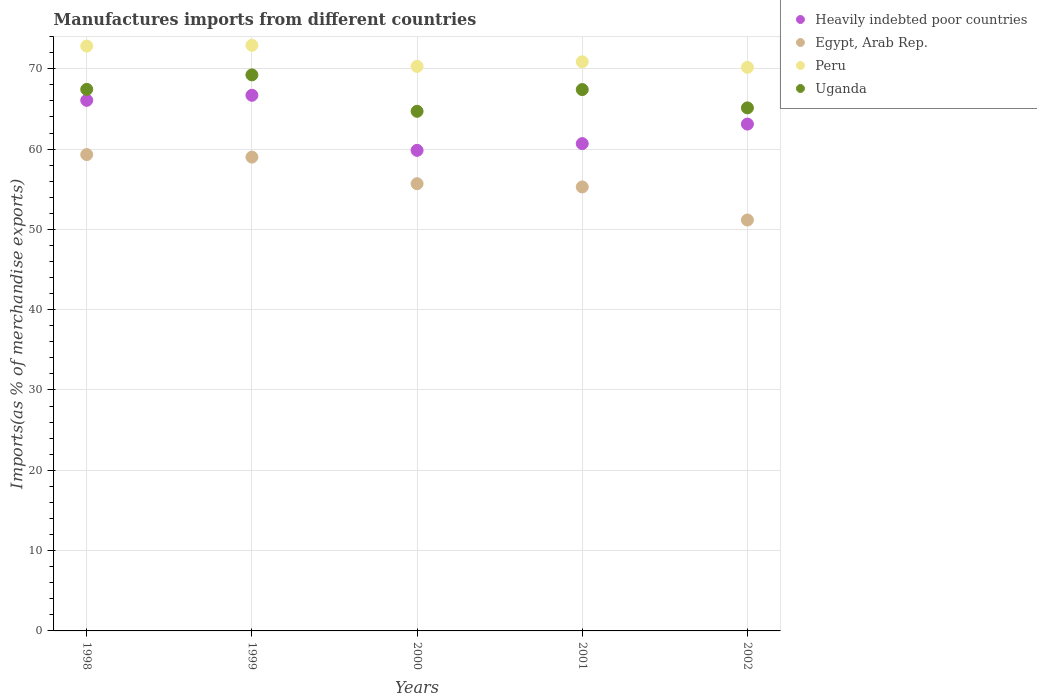What is the percentage of imports to different countries in Heavily indebted poor countries in 1999?
Offer a very short reply. 66.7. Across all years, what is the maximum percentage of imports to different countries in Uganda?
Offer a terse response. 69.24. Across all years, what is the minimum percentage of imports to different countries in Peru?
Offer a terse response. 70.18. In which year was the percentage of imports to different countries in Uganda maximum?
Keep it short and to the point. 1999. In which year was the percentage of imports to different countries in Uganda minimum?
Keep it short and to the point. 2000. What is the total percentage of imports to different countries in Heavily indebted poor countries in the graph?
Give a very brief answer. 316.4. What is the difference between the percentage of imports to different countries in Peru in 1998 and that in 2001?
Keep it short and to the point. 1.96. What is the difference between the percentage of imports to different countries in Egypt, Arab Rep. in 1999 and the percentage of imports to different countries in Heavily indebted poor countries in 2000?
Keep it short and to the point. -0.84. What is the average percentage of imports to different countries in Egypt, Arab Rep. per year?
Offer a terse response. 56.09. In the year 1998, what is the difference between the percentage of imports to different countries in Egypt, Arab Rep. and percentage of imports to different countries in Peru?
Make the answer very short. -13.51. In how many years, is the percentage of imports to different countries in Peru greater than 54 %?
Your answer should be very brief. 5. What is the ratio of the percentage of imports to different countries in Heavily indebted poor countries in 1998 to that in 2002?
Give a very brief answer. 1.05. What is the difference between the highest and the second highest percentage of imports to different countries in Peru?
Offer a very short reply. 0.09. What is the difference between the highest and the lowest percentage of imports to different countries in Uganda?
Make the answer very short. 4.53. In how many years, is the percentage of imports to different countries in Egypt, Arab Rep. greater than the average percentage of imports to different countries in Egypt, Arab Rep. taken over all years?
Offer a very short reply. 2. Is it the case that in every year, the sum of the percentage of imports to different countries in Peru and percentage of imports to different countries in Heavily indebted poor countries  is greater than the sum of percentage of imports to different countries in Egypt, Arab Rep. and percentage of imports to different countries in Uganda?
Provide a short and direct response. No. Does the percentage of imports to different countries in Peru monotonically increase over the years?
Your answer should be very brief. No. Is the percentage of imports to different countries in Egypt, Arab Rep. strictly greater than the percentage of imports to different countries in Uganda over the years?
Provide a succinct answer. No. Is the percentage of imports to different countries in Peru strictly less than the percentage of imports to different countries in Egypt, Arab Rep. over the years?
Provide a short and direct response. No. What is the difference between two consecutive major ticks on the Y-axis?
Offer a terse response. 10. Does the graph contain grids?
Your answer should be very brief. Yes. What is the title of the graph?
Ensure brevity in your answer.  Manufactures imports from different countries. What is the label or title of the X-axis?
Ensure brevity in your answer.  Years. What is the label or title of the Y-axis?
Offer a terse response. Imports(as % of merchandise exports). What is the Imports(as % of merchandise exports) in Heavily indebted poor countries in 1998?
Provide a short and direct response. 66.07. What is the Imports(as % of merchandise exports) in Egypt, Arab Rep. in 1998?
Provide a succinct answer. 59.32. What is the Imports(as % of merchandise exports) of Peru in 1998?
Your response must be concise. 72.83. What is the Imports(as % of merchandise exports) in Uganda in 1998?
Ensure brevity in your answer.  67.44. What is the Imports(as % of merchandise exports) in Heavily indebted poor countries in 1999?
Offer a terse response. 66.7. What is the Imports(as % of merchandise exports) of Egypt, Arab Rep. in 1999?
Ensure brevity in your answer.  59. What is the Imports(as % of merchandise exports) in Peru in 1999?
Provide a succinct answer. 72.92. What is the Imports(as % of merchandise exports) in Uganda in 1999?
Offer a terse response. 69.24. What is the Imports(as % of merchandise exports) of Heavily indebted poor countries in 2000?
Your answer should be compact. 59.84. What is the Imports(as % of merchandise exports) in Egypt, Arab Rep. in 2000?
Keep it short and to the point. 55.69. What is the Imports(as % of merchandise exports) in Peru in 2000?
Offer a terse response. 70.29. What is the Imports(as % of merchandise exports) of Uganda in 2000?
Make the answer very short. 64.7. What is the Imports(as % of merchandise exports) in Heavily indebted poor countries in 2001?
Make the answer very short. 60.68. What is the Imports(as % of merchandise exports) in Egypt, Arab Rep. in 2001?
Make the answer very short. 55.28. What is the Imports(as % of merchandise exports) of Peru in 2001?
Your answer should be very brief. 70.87. What is the Imports(as % of merchandise exports) of Uganda in 2001?
Provide a succinct answer. 67.41. What is the Imports(as % of merchandise exports) of Heavily indebted poor countries in 2002?
Your answer should be very brief. 63.11. What is the Imports(as % of merchandise exports) in Egypt, Arab Rep. in 2002?
Ensure brevity in your answer.  51.16. What is the Imports(as % of merchandise exports) in Peru in 2002?
Your response must be concise. 70.18. What is the Imports(as % of merchandise exports) of Uganda in 2002?
Provide a succinct answer. 65.13. Across all years, what is the maximum Imports(as % of merchandise exports) in Heavily indebted poor countries?
Keep it short and to the point. 66.7. Across all years, what is the maximum Imports(as % of merchandise exports) in Egypt, Arab Rep.?
Offer a terse response. 59.32. Across all years, what is the maximum Imports(as % of merchandise exports) in Peru?
Offer a terse response. 72.92. Across all years, what is the maximum Imports(as % of merchandise exports) of Uganda?
Provide a succinct answer. 69.24. Across all years, what is the minimum Imports(as % of merchandise exports) in Heavily indebted poor countries?
Your answer should be compact. 59.84. Across all years, what is the minimum Imports(as % of merchandise exports) in Egypt, Arab Rep.?
Your answer should be compact. 51.16. Across all years, what is the minimum Imports(as % of merchandise exports) of Peru?
Keep it short and to the point. 70.18. Across all years, what is the minimum Imports(as % of merchandise exports) in Uganda?
Make the answer very short. 64.7. What is the total Imports(as % of merchandise exports) in Heavily indebted poor countries in the graph?
Your answer should be compact. 316.4. What is the total Imports(as % of merchandise exports) of Egypt, Arab Rep. in the graph?
Provide a succinct answer. 280.45. What is the total Imports(as % of merchandise exports) in Peru in the graph?
Ensure brevity in your answer.  357.1. What is the total Imports(as % of merchandise exports) in Uganda in the graph?
Offer a very short reply. 333.92. What is the difference between the Imports(as % of merchandise exports) in Heavily indebted poor countries in 1998 and that in 1999?
Your answer should be compact. -0.63. What is the difference between the Imports(as % of merchandise exports) in Egypt, Arab Rep. in 1998 and that in 1999?
Make the answer very short. 0.32. What is the difference between the Imports(as % of merchandise exports) of Peru in 1998 and that in 1999?
Ensure brevity in your answer.  -0.09. What is the difference between the Imports(as % of merchandise exports) in Uganda in 1998 and that in 1999?
Ensure brevity in your answer.  -1.8. What is the difference between the Imports(as % of merchandise exports) in Heavily indebted poor countries in 1998 and that in 2000?
Offer a terse response. 6.23. What is the difference between the Imports(as % of merchandise exports) in Egypt, Arab Rep. in 1998 and that in 2000?
Your answer should be very brief. 3.63. What is the difference between the Imports(as % of merchandise exports) of Peru in 1998 and that in 2000?
Provide a short and direct response. 2.53. What is the difference between the Imports(as % of merchandise exports) of Uganda in 1998 and that in 2000?
Your answer should be very brief. 2.73. What is the difference between the Imports(as % of merchandise exports) of Heavily indebted poor countries in 1998 and that in 2001?
Your answer should be compact. 5.39. What is the difference between the Imports(as % of merchandise exports) in Egypt, Arab Rep. in 1998 and that in 2001?
Keep it short and to the point. 4.03. What is the difference between the Imports(as % of merchandise exports) of Peru in 1998 and that in 2001?
Make the answer very short. 1.96. What is the difference between the Imports(as % of merchandise exports) in Uganda in 1998 and that in 2001?
Provide a succinct answer. 0.03. What is the difference between the Imports(as % of merchandise exports) in Heavily indebted poor countries in 1998 and that in 2002?
Provide a succinct answer. 2.96. What is the difference between the Imports(as % of merchandise exports) of Egypt, Arab Rep. in 1998 and that in 2002?
Make the answer very short. 8.15. What is the difference between the Imports(as % of merchandise exports) in Peru in 1998 and that in 2002?
Give a very brief answer. 2.65. What is the difference between the Imports(as % of merchandise exports) in Uganda in 1998 and that in 2002?
Your answer should be compact. 2.31. What is the difference between the Imports(as % of merchandise exports) of Heavily indebted poor countries in 1999 and that in 2000?
Your response must be concise. 6.86. What is the difference between the Imports(as % of merchandise exports) of Egypt, Arab Rep. in 1999 and that in 2000?
Provide a succinct answer. 3.31. What is the difference between the Imports(as % of merchandise exports) of Peru in 1999 and that in 2000?
Your answer should be compact. 2.63. What is the difference between the Imports(as % of merchandise exports) of Uganda in 1999 and that in 2000?
Your answer should be very brief. 4.53. What is the difference between the Imports(as % of merchandise exports) in Heavily indebted poor countries in 1999 and that in 2001?
Ensure brevity in your answer.  6.02. What is the difference between the Imports(as % of merchandise exports) in Egypt, Arab Rep. in 1999 and that in 2001?
Your answer should be compact. 3.72. What is the difference between the Imports(as % of merchandise exports) of Peru in 1999 and that in 2001?
Give a very brief answer. 2.05. What is the difference between the Imports(as % of merchandise exports) of Uganda in 1999 and that in 2001?
Provide a succinct answer. 1.83. What is the difference between the Imports(as % of merchandise exports) of Heavily indebted poor countries in 1999 and that in 2002?
Offer a terse response. 3.59. What is the difference between the Imports(as % of merchandise exports) of Egypt, Arab Rep. in 1999 and that in 2002?
Make the answer very short. 7.83. What is the difference between the Imports(as % of merchandise exports) in Peru in 1999 and that in 2002?
Keep it short and to the point. 2.74. What is the difference between the Imports(as % of merchandise exports) of Uganda in 1999 and that in 2002?
Give a very brief answer. 4.11. What is the difference between the Imports(as % of merchandise exports) in Heavily indebted poor countries in 2000 and that in 2001?
Your response must be concise. -0.84. What is the difference between the Imports(as % of merchandise exports) in Egypt, Arab Rep. in 2000 and that in 2001?
Offer a terse response. 0.4. What is the difference between the Imports(as % of merchandise exports) in Peru in 2000 and that in 2001?
Offer a very short reply. -0.58. What is the difference between the Imports(as % of merchandise exports) of Uganda in 2000 and that in 2001?
Provide a short and direct response. -2.7. What is the difference between the Imports(as % of merchandise exports) in Heavily indebted poor countries in 2000 and that in 2002?
Provide a succinct answer. -3.27. What is the difference between the Imports(as % of merchandise exports) of Egypt, Arab Rep. in 2000 and that in 2002?
Your answer should be compact. 4.52. What is the difference between the Imports(as % of merchandise exports) of Peru in 2000 and that in 2002?
Ensure brevity in your answer.  0.12. What is the difference between the Imports(as % of merchandise exports) of Uganda in 2000 and that in 2002?
Provide a short and direct response. -0.43. What is the difference between the Imports(as % of merchandise exports) in Heavily indebted poor countries in 2001 and that in 2002?
Give a very brief answer. -2.43. What is the difference between the Imports(as % of merchandise exports) in Egypt, Arab Rep. in 2001 and that in 2002?
Make the answer very short. 4.12. What is the difference between the Imports(as % of merchandise exports) of Peru in 2001 and that in 2002?
Provide a succinct answer. 0.7. What is the difference between the Imports(as % of merchandise exports) in Uganda in 2001 and that in 2002?
Provide a short and direct response. 2.28. What is the difference between the Imports(as % of merchandise exports) in Heavily indebted poor countries in 1998 and the Imports(as % of merchandise exports) in Egypt, Arab Rep. in 1999?
Your answer should be compact. 7.07. What is the difference between the Imports(as % of merchandise exports) of Heavily indebted poor countries in 1998 and the Imports(as % of merchandise exports) of Peru in 1999?
Your answer should be very brief. -6.85. What is the difference between the Imports(as % of merchandise exports) of Heavily indebted poor countries in 1998 and the Imports(as % of merchandise exports) of Uganda in 1999?
Offer a very short reply. -3.17. What is the difference between the Imports(as % of merchandise exports) in Egypt, Arab Rep. in 1998 and the Imports(as % of merchandise exports) in Peru in 1999?
Ensure brevity in your answer.  -13.61. What is the difference between the Imports(as % of merchandise exports) in Egypt, Arab Rep. in 1998 and the Imports(as % of merchandise exports) in Uganda in 1999?
Provide a short and direct response. -9.92. What is the difference between the Imports(as % of merchandise exports) in Peru in 1998 and the Imports(as % of merchandise exports) in Uganda in 1999?
Your response must be concise. 3.59. What is the difference between the Imports(as % of merchandise exports) of Heavily indebted poor countries in 1998 and the Imports(as % of merchandise exports) of Egypt, Arab Rep. in 2000?
Your answer should be compact. 10.38. What is the difference between the Imports(as % of merchandise exports) of Heavily indebted poor countries in 1998 and the Imports(as % of merchandise exports) of Peru in 2000?
Your response must be concise. -4.22. What is the difference between the Imports(as % of merchandise exports) of Heavily indebted poor countries in 1998 and the Imports(as % of merchandise exports) of Uganda in 2000?
Your answer should be compact. 1.36. What is the difference between the Imports(as % of merchandise exports) of Egypt, Arab Rep. in 1998 and the Imports(as % of merchandise exports) of Peru in 2000?
Provide a succinct answer. -10.98. What is the difference between the Imports(as % of merchandise exports) in Egypt, Arab Rep. in 1998 and the Imports(as % of merchandise exports) in Uganda in 2000?
Offer a terse response. -5.39. What is the difference between the Imports(as % of merchandise exports) in Peru in 1998 and the Imports(as % of merchandise exports) in Uganda in 2000?
Your answer should be compact. 8.12. What is the difference between the Imports(as % of merchandise exports) of Heavily indebted poor countries in 1998 and the Imports(as % of merchandise exports) of Egypt, Arab Rep. in 2001?
Provide a short and direct response. 10.79. What is the difference between the Imports(as % of merchandise exports) in Heavily indebted poor countries in 1998 and the Imports(as % of merchandise exports) in Peru in 2001?
Your answer should be compact. -4.8. What is the difference between the Imports(as % of merchandise exports) of Heavily indebted poor countries in 1998 and the Imports(as % of merchandise exports) of Uganda in 2001?
Your answer should be very brief. -1.34. What is the difference between the Imports(as % of merchandise exports) of Egypt, Arab Rep. in 1998 and the Imports(as % of merchandise exports) of Peru in 2001?
Your answer should be compact. -11.56. What is the difference between the Imports(as % of merchandise exports) of Egypt, Arab Rep. in 1998 and the Imports(as % of merchandise exports) of Uganda in 2001?
Offer a terse response. -8.09. What is the difference between the Imports(as % of merchandise exports) of Peru in 1998 and the Imports(as % of merchandise exports) of Uganda in 2001?
Keep it short and to the point. 5.42. What is the difference between the Imports(as % of merchandise exports) in Heavily indebted poor countries in 1998 and the Imports(as % of merchandise exports) in Egypt, Arab Rep. in 2002?
Your response must be concise. 14.9. What is the difference between the Imports(as % of merchandise exports) in Heavily indebted poor countries in 1998 and the Imports(as % of merchandise exports) in Peru in 2002?
Your response must be concise. -4.11. What is the difference between the Imports(as % of merchandise exports) in Heavily indebted poor countries in 1998 and the Imports(as % of merchandise exports) in Uganda in 2002?
Keep it short and to the point. 0.94. What is the difference between the Imports(as % of merchandise exports) of Egypt, Arab Rep. in 1998 and the Imports(as % of merchandise exports) of Peru in 2002?
Make the answer very short. -10.86. What is the difference between the Imports(as % of merchandise exports) in Egypt, Arab Rep. in 1998 and the Imports(as % of merchandise exports) in Uganda in 2002?
Provide a succinct answer. -5.82. What is the difference between the Imports(as % of merchandise exports) of Peru in 1998 and the Imports(as % of merchandise exports) of Uganda in 2002?
Ensure brevity in your answer.  7.7. What is the difference between the Imports(as % of merchandise exports) of Heavily indebted poor countries in 1999 and the Imports(as % of merchandise exports) of Egypt, Arab Rep. in 2000?
Make the answer very short. 11.01. What is the difference between the Imports(as % of merchandise exports) in Heavily indebted poor countries in 1999 and the Imports(as % of merchandise exports) in Peru in 2000?
Make the answer very short. -3.6. What is the difference between the Imports(as % of merchandise exports) of Heavily indebted poor countries in 1999 and the Imports(as % of merchandise exports) of Uganda in 2000?
Offer a terse response. 1.99. What is the difference between the Imports(as % of merchandise exports) in Egypt, Arab Rep. in 1999 and the Imports(as % of merchandise exports) in Peru in 2000?
Offer a very short reply. -11.29. What is the difference between the Imports(as % of merchandise exports) in Egypt, Arab Rep. in 1999 and the Imports(as % of merchandise exports) in Uganda in 2000?
Keep it short and to the point. -5.7. What is the difference between the Imports(as % of merchandise exports) in Peru in 1999 and the Imports(as % of merchandise exports) in Uganda in 2000?
Offer a terse response. 8.22. What is the difference between the Imports(as % of merchandise exports) in Heavily indebted poor countries in 1999 and the Imports(as % of merchandise exports) in Egypt, Arab Rep. in 2001?
Offer a terse response. 11.41. What is the difference between the Imports(as % of merchandise exports) of Heavily indebted poor countries in 1999 and the Imports(as % of merchandise exports) of Peru in 2001?
Make the answer very short. -4.18. What is the difference between the Imports(as % of merchandise exports) of Heavily indebted poor countries in 1999 and the Imports(as % of merchandise exports) of Uganda in 2001?
Your response must be concise. -0.71. What is the difference between the Imports(as % of merchandise exports) in Egypt, Arab Rep. in 1999 and the Imports(as % of merchandise exports) in Peru in 2001?
Your answer should be very brief. -11.87. What is the difference between the Imports(as % of merchandise exports) in Egypt, Arab Rep. in 1999 and the Imports(as % of merchandise exports) in Uganda in 2001?
Offer a very short reply. -8.41. What is the difference between the Imports(as % of merchandise exports) of Peru in 1999 and the Imports(as % of merchandise exports) of Uganda in 2001?
Make the answer very short. 5.51. What is the difference between the Imports(as % of merchandise exports) of Heavily indebted poor countries in 1999 and the Imports(as % of merchandise exports) of Egypt, Arab Rep. in 2002?
Provide a succinct answer. 15.53. What is the difference between the Imports(as % of merchandise exports) in Heavily indebted poor countries in 1999 and the Imports(as % of merchandise exports) in Peru in 2002?
Keep it short and to the point. -3.48. What is the difference between the Imports(as % of merchandise exports) in Heavily indebted poor countries in 1999 and the Imports(as % of merchandise exports) in Uganda in 2002?
Offer a terse response. 1.57. What is the difference between the Imports(as % of merchandise exports) in Egypt, Arab Rep. in 1999 and the Imports(as % of merchandise exports) in Peru in 2002?
Provide a short and direct response. -11.18. What is the difference between the Imports(as % of merchandise exports) in Egypt, Arab Rep. in 1999 and the Imports(as % of merchandise exports) in Uganda in 2002?
Your answer should be very brief. -6.13. What is the difference between the Imports(as % of merchandise exports) in Peru in 1999 and the Imports(as % of merchandise exports) in Uganda in 2002?
Your answer should be very brief. 7.79. What is the difference between the Imports(as % of merchandise exports) of Heavily indebted poor countries in 2000 and the Imports(as % of merchandise exports) of Egypt, Arab Rep. in 2001?
Your answer should be compact. 4.56. What is the difference between the Imports(as % of merchandise exports) in Heavily indebted poor countries in 2000 and the Imports(as % of merchandise exports) in Peru in 2001?
Offer a terse response. -11.03. What is the difference between the Imports(as % of merchandise exports) of Heavily indebted poor countries in 2000 and the Imports(as % of merchandise exports) of Uganda in 2001?
Ensure brevity in your answer.  -7.57. What is the difference between the Imports(as % of merchandise exports) of Egypt, Arab Rep. in 2000 and the Imports(as % of merchandise exports) of Peru in 2001?
Your answer should be compact. -15.19. What is the difference between the Imports(as % of merchandise exports) in Egypt, Arab Rep. in 2000 and the Imports(as % of merchandise exports) in Uganda in 2001?
Your response must be concise. -11.72. What is the difference between the Imports(as % of merchandise exports) in Peru in 2000 and the Imports(as % of merchandise exports) in Uganda in 2001?
Give a very brief answer. 2.88. What is the difference between the Imports(as % of merchandise exports) in Heavily indebted poor countries in 2000 and the Imports(as % of merchandise exports) in Egypt, Arab Rep. in 2002?
Your answer should be compact. 8.68. What is the difference between the Imports(as % of merchandise exports) of Heavily indebted poor countries in 2000 and the Imports(as % of merchandise exports) of Peru in 2002?
Give a very brief answer. -10.34. What is the difference between the Imports(as % of merchandise exports) of Heavily indebted poor countries in 2000 and the Imports(as % of merchandise exports) of Uganda in 2002?
Offer a terse response. -5.29. What is the difference between the Imports(as % of merchandise exports) of Egypt, Arab Rep. in 2000 and the Imports(as % of merchandise exports) of Peru in 2002?
Make the answer very short. -14.49. What is the difference between the Imports(as % of merchandise exports) of Egypt, Arab Rep. in 2000 and the Imports(as % of merchandise exports) of Uganda in 2002?
Your response must be concise. -9.44. What is the difference between the Imports(as % of merchandise exports) in Peru in 2000 and the Imports(as % of merchandise exports) in Uganda in 2002?
Your answer should be compact. 5.16. What is the difference between the Imports(as % of merchandise exports) of Heavily indebted poor countries in 2001 and the Imports(as % of merchandise exports) of Egypt, Arab Rep. in 2002?
Your response must be concise. 9.51. What is the difference between the Imports(as % of merchandise exports) in Heavily indebted poor countries in 2001 and the Imports(as % of merchandise exports) in Peru in 2002?
Your answer should be compact. -9.5. What is the difference between the Imports(as % of merchandise exports) of Heavily indebted poor countries in 2001 and the Imports(as % of merchandise exports) of Uganda in 2002?
Offer a terse response. -4.45. What is the difference between the Imports(as % of merchandise exports) of Egypt, Arab Rep. in 2001 and the Imports(as % of merchandise exports) of Peru in 2002?
Keep it short and to the point. -14.89. What is the difference between the Imports(as % of merchandise exports) in Egypt, Arab Rep. in 2001 and the Imports(as % of merchandise exports) in Uganda in 2002?
Offer a very short reply. -9.85. What is the difference between the Imports(as % of merchandise exports) of Peru in 2001 and the Imports(as % of merchandise exports) of Uganda in 2002?
Provide a succinct answer. 5.74. What is the average Imports(as % of merchandise exports) of Heavily indebted poor countries per year?
Offer a terse response. 63.28. What is the average Imports(as % of merchandise exports) of Egypt, Arab Rep. per year?
Your answer should be very brief. 56.09. What is the average Imports(as % of merchandise exports) in Peru per year?
Provide a short and direct response. 71.42. What is the average Imports(as % of merchandise exports) in Uganda per year?
Give a very brief answer. 66.78. In the year 1998, what is the difference between the Imports(as % of merchandise exports) of Heavily indebted poor countries and Imports(as % of merchandise exports) of Egypt, Arab Rep.?
Your response must be concise. 6.75. In the year 1998, what is the difference between the Imports(as % of merchandise exports) of Heavily indebted poor countries and Imports(as % of merchandise exports) of Peru?
Provide a succinct answer. -6.76. In the year 1998, what is the difference between the Imports(as % of merchandise exports) of Heavily indebted poor countries and Imports(as % of merchandise exports) of Uganda?
Provide a short and direct response. -1.37. In the year 1998, what is the difference between the Imports(as % of merchandise exports) of Egypt, Arab Rep. and Imports(as % of merchandise exports) of Peru?
Your answer should be very brief. -13.51. In the year 1998, what is the difference between the Imports(as % of merchandise exports) of Egypt, Arab Rep. and Imports(as % of merchandise exports) of Uganda?
Offer a very short reply. -8.12. In the year 1998, what is the difference between the Imports(as % of merchandise exports) in Peru and Imports(as % of merchandise exports) in Uganda?
Your answer should be compact. 5.39. In the year 1999, what is the difference between the Imports(as % of merchandise exports) in Heavily indebted poor countries and Imports(as % of merchandise exports) in Egypt, Arab Rep.?
Provide a succinct answer. 7.7. In the year 1999, what is the difference between the Imports(as % of merchandise exports) in Heavily indebted poor countries and Imports(as % of merchandise exports) in Peru?
Your answer should be compact. -6.22. In the year 1999, what is the difference between the Imports(as % of merchandise exports) in Heavily indebted poor countries and Imports(as % of merchandise exports) in Uganda?
Keep it short and to the point. -2.54. In the year 1999, what is the difference between the Imports(as % of merchandise exports) of Egypt, Arab Rep. and Imports(as % of merchandise exports) of Peru?
Ensure brevity in your answer.  -13.92. In the year 1999, what is the difference between the Imports(as % of merchandise exports) in Egypt, Arab Rep. and Imports(as % of merchandise exports) in Uganda?
Provide a short and direct response. -10.24. In the year 1999, what is the difference between the Imports(as % of merchandise exports) in Peru and Imports(as % of merchandise exports) in Uganda?
Offer a terse response. 3.68. In the year 2000, what is the difference between the Imports(as % of merchandise exports) of Heavily indebted poor countries and Imports(as % of merchandise exports) of Egypt, Arab Rep.?
Provide a succinct answer. 4.15. In the year 2000, what is the difference between the Imports(as % of merchandise exports) of Heavily indebted poor countries and Imports(as % of merchandise exports) of Peru?
Make the answer very short. -10.45. In the year 2000, what is the difference between the Imports(as % of merchandise exports) in Heavily indebted poor countries and Imports(as % of merchandise exports) in Uganda?
Offer a very short reply. -4.86. In the year 2000, what is the difference between the Imports(as % of merchandise exports) of Egypt, Arab Rep. and Imports(as % of merchandise exports) of Peru?
Your answer should be compact. -14.61. In the year 2000, what is the difference between the Imports(as % of merchandise exports) in Egypt, Arab Rep. and Imports(as % of merchandise exports) in Uganda?
Keep it short and to the point. -9.02. In the year 2000, what is the difference between the Imports(as % of merchandise exports) of Peru and Imports(as % of merchandise exports) of Uganda?
Provide a short and direct response. 5.59. In the year 2001, what is the difference between the Imports(as % of merchandise exports) of Heavily indebted poor countries and Imports(as % of merchandise exports) of Egypt, Arab Rep.?
Keep it short and to the point. 5.4. In the year 2001, what is the difference between the Imports(as % of merchandise exports) in Heavily indebted poor countries and Imports(as % of merchandise exports) in Peru?
Provide a short and direct response. -10.19. In the year 2001, what is the difference between the Imports(as % of merchandise exports) of Heavily indebted poor countries and Imports(as % of merchandise exports) of Uganda?
Provide a short and direct response. -6.73. In the year 2001, what is the difference between the Imports(as % of merchandise exports) in Egypt, Arab Rep. and Imports(as % of merchandise exports) in Peru?
Keep it short and to the point. -15.59. In the year 2001, what is the difference between the Imports(as % of merchandise exports) of Egypt, Arab Rep. and Imports(as % of merchandise exports) of Uganda?
Offer a very short reply. -12.13. In the year 2001, what is the difference between the Imports(as % of merchandise exports) of Peru and Imports(as % of merchandise exports) of Uganda?
Provide a succinct answer. 3.46. In the year 2002, what is the difference between the Imports(as % of merchandise exports) of Heavily indebted poor countries and Imports(as % of merchandise exports) of Egypt, Arab Rep.?
Keep it short and to the point. 11.95. In the year 2002, what is the difference between the Imports(as % of merchandise exports) in Heavily indebted poor countries and Imports(as % of merchandise exports) in Peru?
Provide a short and direct response. -7.07. In the year 2002, what is the difference between the Imports(as % of merchandise exports) in Heavily indebted poor countries and Imports(as % of merchandise exports) in Uganda?
Ensure brevity in your answer.  -2.02. In the year 2002, what is the difference between the Imports(as % of merchandise exports) in Egypt, Arab Rep. and Imports(as % of merchandise exports) in Peru?
Offer a very short reply. -19.01. In the year 2002, what is the difference between the Imports(as % of merchandise exports) in Egypt, Arab Rep. and Imports(as % of merchandise exports) in Uganda?
Provide a succinct answer. -13.97. In the year 2002, what is the difference between the Imports(as % of merchandise exports) of Peru and Imports(as % of merchandise exports) of Uganda?
Offer a very short reply. 5.05. What is the ratio of the Imports(as % of merchandise exports) in Heavily indebted poor countries in 1998 to that in 1999?
Your response must be concise. 0.99. What is the ratio of the Imports(as % of merchandise exports) of Egypt, Arab Rep. in 1998 to that in 1999?
Offer a terse response. 1.01. What is the ratio of the Imports(as % of merchandise exports) in Peru in 1998 to that in 1999?
Make the answer very short. 1. What is the ratio of the Imports(as % of merchandise exports) in Uganda in 1998 to that in 1999?
Ensure brevity in your answer.  0.97. What is the ratio of the Imports(as % of merchandise exports) of Heavily indebted poor countries in 1998 to that in 2000?
Offer a terse response. 1.1. What is the ratio of the Imports(as % of merchandise exports) in Egypt, Arab Rep. in 1998 to that in 2000?
Provide a short and direct response. 1.07. What is the ratio of the Imports(as % of merchandise exports) in Peru in 1998 to that in 2000?
Keep it short and to the point. 1.04. What is the ratio of the Imports(as % of merchandise exports) in Uganda in 1998 to that in 2000?
Ensure brevity in your answer.  1.04. What is the ratio of the Imports(as % of merchandise exports) of Heavily indebted poor countries in 1998 to that in 2001?
Your answer should be very brief. 1.09. What is the ratio of the Imports(as % of merchandise exports) in Egypt, Arab Rep. in 1998 to that in 2001?
Give a very brief answer. 1.07. What is the ratio of the Imports(as % of merchandise exports) of Peru in 1998 to that in 2001?
Provide a succinct answer. 1.03. What is the ratio of the Imports(as % of merchandise exports) of Uganda in 1998 to that in 2001?
Offer a very short reply. 1. What is the ratio of the Imports(as % of merchandise exports) of Heavily indebted poor countries in 1998 to that in 2002?
Offer a very short reply. 1.05. What is the ratio of the Imports(as % of merchandise exports) of Egypt, Arab Rep. in 1998 to that in 2002?
Provide a succinct answer. 1.16. What is the ratio of the Imports(as % of merchandise exports) in Peru in 1998 to that in 2002?
Your answer should be very brief. 1.04. What is the ratio of the Imports(as % of merchandise exports) in Uganda in 1998 to that in 2002?
Provide a succinct answer. 1.04. What is the ratio of the Imports(as % of merchandise exports) of Heavily indebted poor countries in 1999 to that in 2000?
Ensure brevity in your answer.  1.11. What is the ratio of the Imports(as % of merchandise exports) of Egypt, Arab Rep. in 1999 to that in 2000?
Make the answer very short. 1.06. What is the ratio of the Imports(as % of merchandise exports) of Peru in 1999 to that in 2000?
Make the answer very short. 1.04. What is the ratio of the Imports(as % of merchandise exports) of Uganda in 1999 to that in 2000?
Your response must be concise. 1.07. What is the ratio of the Imports(as % of merchandise exports) in Heavily indebted poor countries in 1999 to that in 2001?
Provide a succinct answer. 1.1. What is the ratio of the Imports(as % of merchandise exports) of Egypt, Arab Rep. in 1999 to that in 2001?
Your response must be concise. 1.07. What is the ratio of the Imports(as % of merchandise exports) of Peru in 1999 to that in 2001?
Offer a very short reply. 1.03. What is the ratio of the Imports(as % of merchandise exports) in Uganda in 1999 to that in 2001?
Your answer should be very brief. 1.03. What is the ratio of the Imports(as % of merchandise exports) of Heavily indebted poor countries in 1999 to that in 2002?
Your answer should be very brief. 1.06. What is the ratio of the Imports(as % of merchandise exports) of Egypt, Arab Rep. in 1999 to that in 2002?
Provide a short and direct response. 1.15. What is the ratio of the Imports(as % of merchandise exports) of Peru in 1999 to that in 2002?
Keep it short and to the point. 1.04. What is the ratio of the Imports(as % of merchandise exports) of Uganda in 1999 to that in 2002?
Your response must be concise. 1.06. What is the ratio of the Imports(as % of merchandise exports) in Heavily indebted poor countries in 2000 to that in 2001?
Offer a very short reply. 0.99. What is the ratio of the Imports(as % of merchandise exports) of Egypt, Arab Rep. in 2000 to that in 2001?
Make the answer very short. 1.01. What is the ratio of the Imports(as % of merchandise exports) in Uganda in 2000 to that in 2001?
Your answer should be compact. 0.96. What is the ratio of the Imports(as % of merchandise exports) in Heavily indebted poor countries in 2000 to that in 2002?
Make the answer very short. 0.95. What is the ratio of the Imports(as % of merchandise exports) of Egypt, Arab Rep. in 2000 to that in 2002?
Offer a very short reply. 1.09. What is the ratio of the Imports(as % of merchandise exports) of Heavily indebted poor countries in 2001 to that in 2002?
Offer a very short reply. 0.96. What is the ratio of the Imports(as % of merchandise exports) in Egypt, Arab Rep. in 2001 to that in 2002?
Offer a very short reply. 1.08. What is the ratio of the Imports(as % of merchandise exports) in Peru in 2001 to that in 2002?
Provide a short and direct response. 1.01. What is the ratio of the Imports(as % of merchandise exports) of Uganda in 2001 to that in 2002?
Give a very brief answer. 1.03. What is the difference between the highest and the second highest Imports(as % of merchandise exports) of Heavily indebted poor countries?
Provide a short and direct response. 0.63. What is the difference between the highest and the second highest Imports(as % of merchandise exports) in Egypt, Arab Rep.?
Provide a succinct answer. 0.32. What is the difference between the highest and the second highest Imports(as % of merchandise exports) of Peru?
Ensure brevity in your answer.  0.09. What is the difference between the highest and the second highest Imports(as % of merchandise exports) of Uganda?
Offer a very short reply. 1.8. What is the difference between the highest and the lowest Imports(as % of merchandise exports) in Heavily indebted poor countries?
Provide a short and direct response. 6.86. What is the difference between the highest and the lowest Imports(as % of merchandise exports) of Egypt, Arab Rep.?
Ensure brevity in your answer.  8.15. What is the difference between the highest and the lowest Imports(as % of merchandise exports) of Peru?
Provide a succinct answer. 2.74. What is the difference between the highest and the lowest Imports(as % of merchandise exports) in Uganda?
Your answer should be compact. 4.53. 